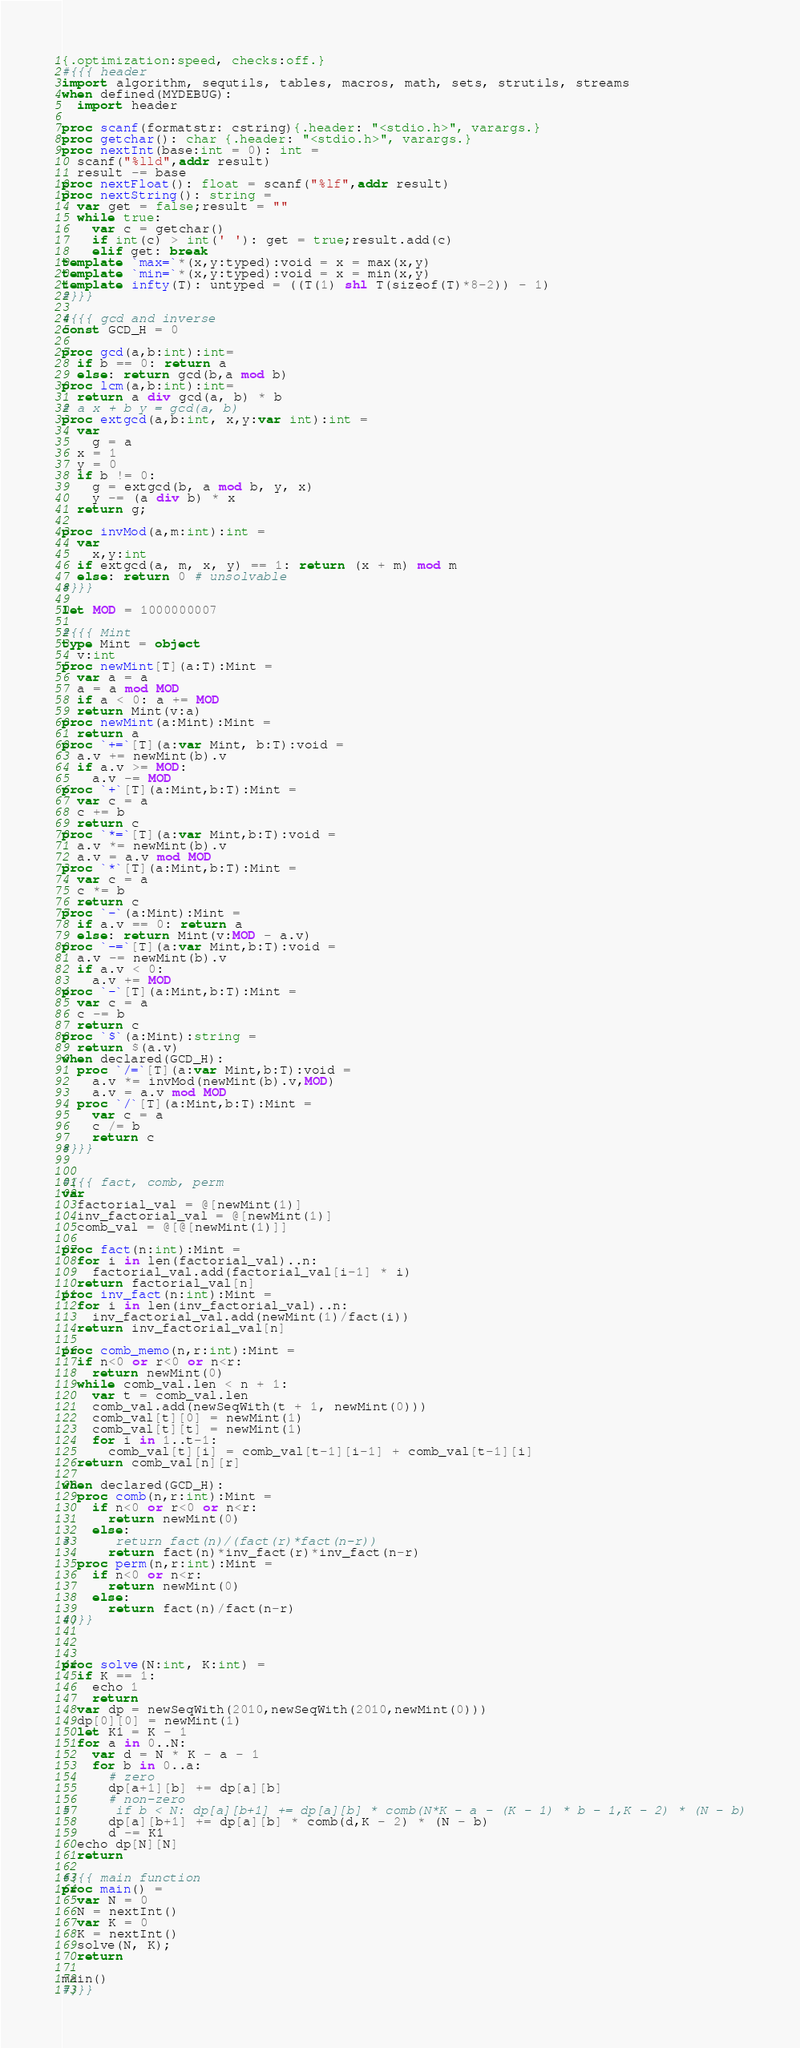<code> <loc_0><loc_0><loc_500><loc_500><_Nim_>{.optimization:speed, checks:off.}
#{{{ header
import algorithm, sequtils, tables, macros, math, sets, strutils, streams
when defined(MYDEBUG):
  import header

proc scanf(formatstr: cstring){.header: "<stdio.h>", varargs.}
proc getchar(): char {.header: "<stdio.h>", varargs.}
proc nextInt(base:int = 0): int =
  scanf("%lld",addr result)
  result -= base
proc nextFloat(): float = scanf("%lf",addr result)
proc nextString(): string =
  var get = false;result = ""
  while true:
    var c = getchar()
    if int(c) > int(' '): get = true;result.add(c)
    elif get: break
template `max=`*(x,y:typed):void = x = max(x,y)
template `min=`*(x,y:typed):void = x = min(x,y)
template infty(T): untyped = ((T(1) shl T(sizeof(T)*8-2)) - 1)
#}}}

#{{{ gcd and inverse
const GCD_H = 0

proc gcd(a,b:int):int=
  if b == 0: return a
  else: return gcd(b,a mod b)
proc lcm(a,b:int):int=
  return a div gcd(a, b) * b
# a x + b y = gcd(a, b)
proc extgcd(a,b:int, x,y:var int):int =
  var
    g = a
  x = 1
  y = 0
  if b != 0:
    g = extgcd(b, a mod b, y, x)
    y -= (a div b) * x
  return g;

proc invMod(a,m:int):int =
  var
    x,y:int
  if extgcd(a, m, x, y) == 1: return (x + m) mod m
  else: return 0 # unsolvable
#}}}

let MOD = 1000000007

#{{{ Mint
type Mint = object
  v:int
proc newMint[T](a:T):Mint =
  var a = a
  a = a mod MOD
  if a < 0: a += MOD
  return Mint(v:a)
proc newMint(a:Mint):Mint =
  return a
proc `+=`[T](a:var Mint, b:T):void =
  a.v += newMint(b).v
  if a.v >= MOD:
    a.v -= MOD
proc `+`[T](a:Mint,b:T):Mint =
  var c = a
  c += b
  return c
proc `*=`[T](a:var Mint,b:T):void =
  a.v *= newMint(b).v
  a.v = a.v mod MOD
proc `*`[T](a:Mint,b:T):Mint =
  var c = a
  c *= b
  return c
proc `-`(a:Mint):Mint =
  if a.v == 0: return a
  else: return Mint(v:MOD - a.v)
proc `-=`[T](a:var Mint,b:T):void =
  a.v -= newMint(b).v
  if a.v < 0:
    a.v += MOD
proc `-`[T](a:Mint,b:T):Mint =
  var c = a
  c -= b
  return c
proc `$`(a:Mint):string =
  return $(a.v)
when declared(GCD_H):
  proc `/=`[T](a:var Mint,b:T):void =
    a.v *= invMod(newMint(b).v,MOD)
    a.v = a.v mod MOD
  proc `/`[T](a:Mint,b:T):Mint =
    var c = a
    c /= b
    return c
#}}}


#{{{ fact, comb, perm
var
  factorial_val = @[newMint(1)]
  inv_factorial_val = @[newMint(1)]
  comb_val = @[@[newMint(1)]]

proc fact(n:int):Mint =
  for i in len(factorial_val)..n:
    factorial_val.add(factorial_val[i-1] * i)
  return factorial_val[n]
proc inv_fact(n:int):Mint =
  for i in len(inv_factorial_val)..n:
    inv_factorial_val.add(newMint(1)/fact(i))
  return inv_factorial_val[n]

proc comb_memo(n,r:int):Mint =
  if n<0 or r<0 or n<r:
    return newMint(0)
  while comb_val.len < n + 1:
    var t = comb_val.len
    comb_val.add(newSeqWith(t + 1, newMint(0)))
    comb_val[t][0] = newMint(1)
    comb_val[t][t] = newMint(1)
    for i in 1..t-1:
      comb_val[t][i] = comb_val[t-1][i-1] + comb_val[t-1][i]
  return comb_val[n][r]

when declared(GCD_H):
  proc comb(n,r:int):Mint =
    if n<0 or r<0 or n<r:
      return newMint(0)
    else:
#      return fact(n)/(fact(r)*fact(n-r))
      return fact(n)*inv_fact(r)*inv_fact(n-r)
  proc perm(n,r:int):Mint =
    if n<0 or n<r:
      return newMint(0)
    else:
      return fact(n)/fact(n-r)
#}}}



proc solve(N:int, K:int) =
  if K == 1:
    echo 1
    return
  var dp = newSeqWith(2010,newSeqWith(2010,newMint(0)))
  dp[0][0] = newMint(1)
  let K1 = K - 1
  for a in 0..N:
    var d = N * K - a - 1
    for b in 0..a:
      # zero
      dp[a+1][b] += dp[a][b]
      # non-zero
#      if b < N: dp[a][b+1] += dp[a][b] * comb(N*K - a - (K - 1) * b - 1,K - 2) * (N - b)
      dp[a][b+1] += dp[a][b] * comb(d,K - 2) * (N - b)
      d -= K1
  echo dp[N][N]
  return

#{{{ main function
proc main() =
  var N = 0
  N = nextInt()
  var K = 0
  K = nextInt()
  solve(N, K);
  return

main()
#}}}</code> 